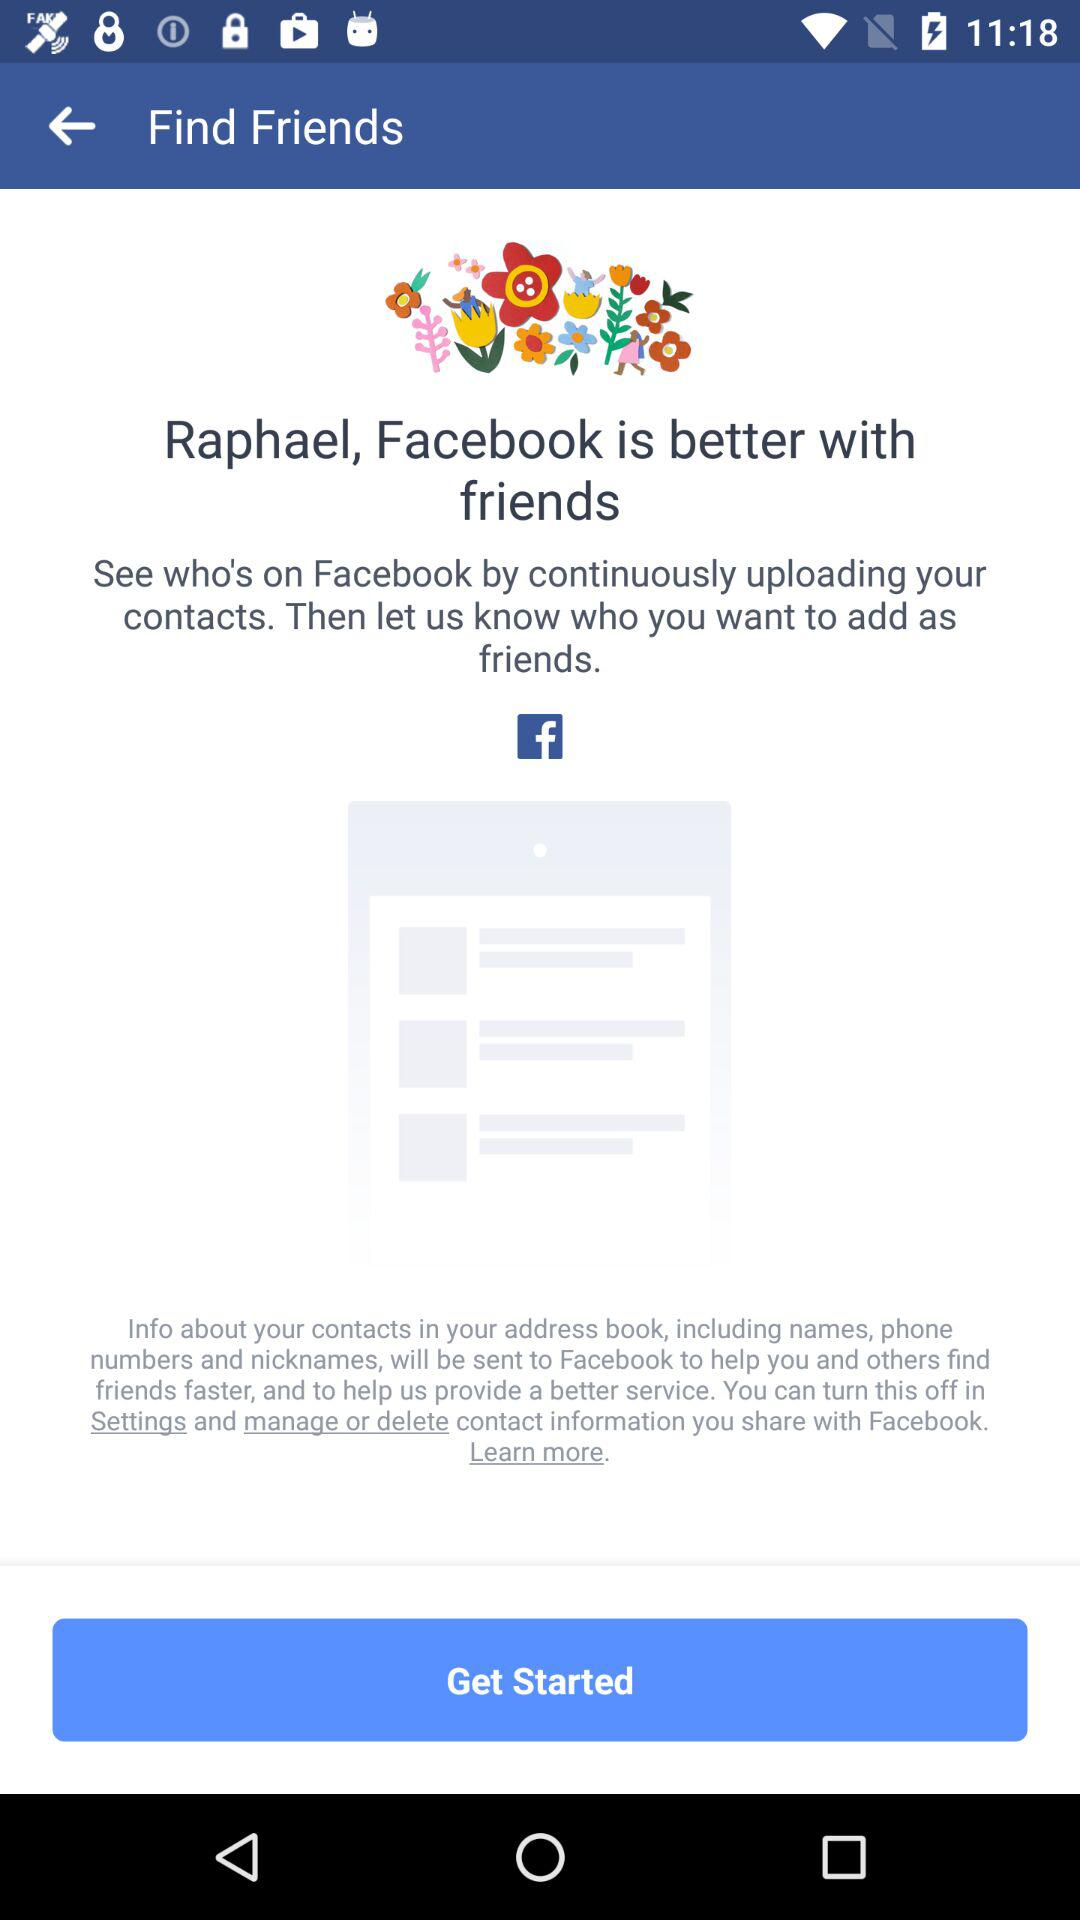Who is this application powered by?
When the provided information is insufficient, respond with <no answer>. <no answer> 